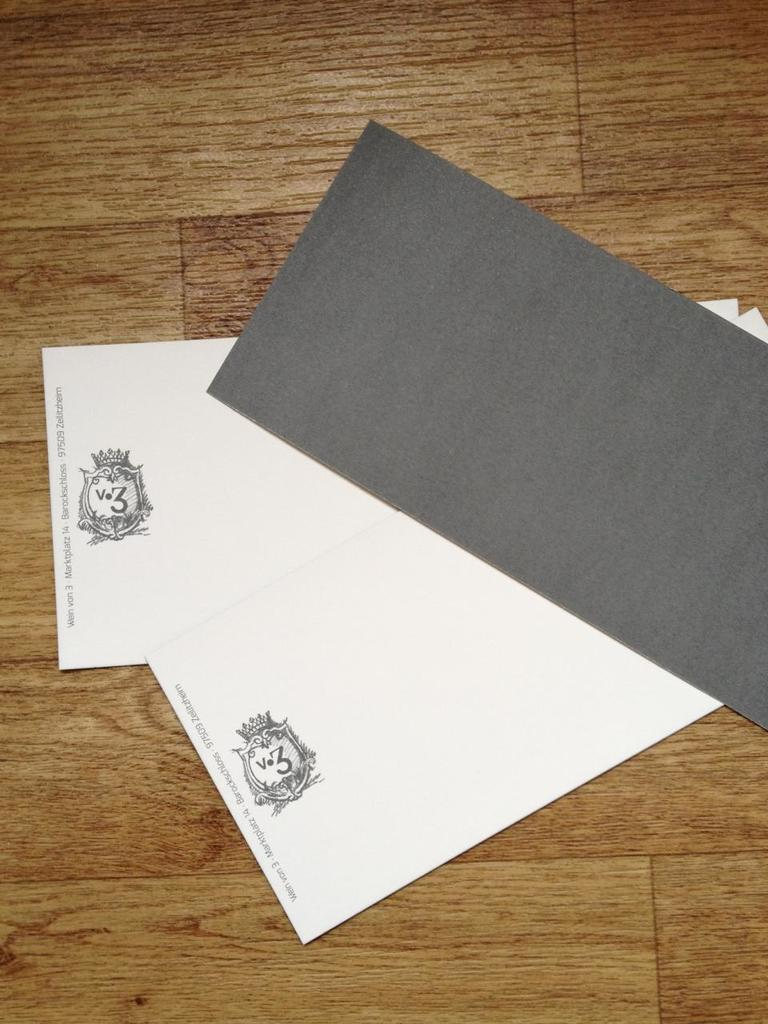What objects are on the wooden surface in the image? There are cards on the wooden surface in the image. What type of machine is used to process the cards in the image? There is no machine present in the image, and the cards are not being processed. 